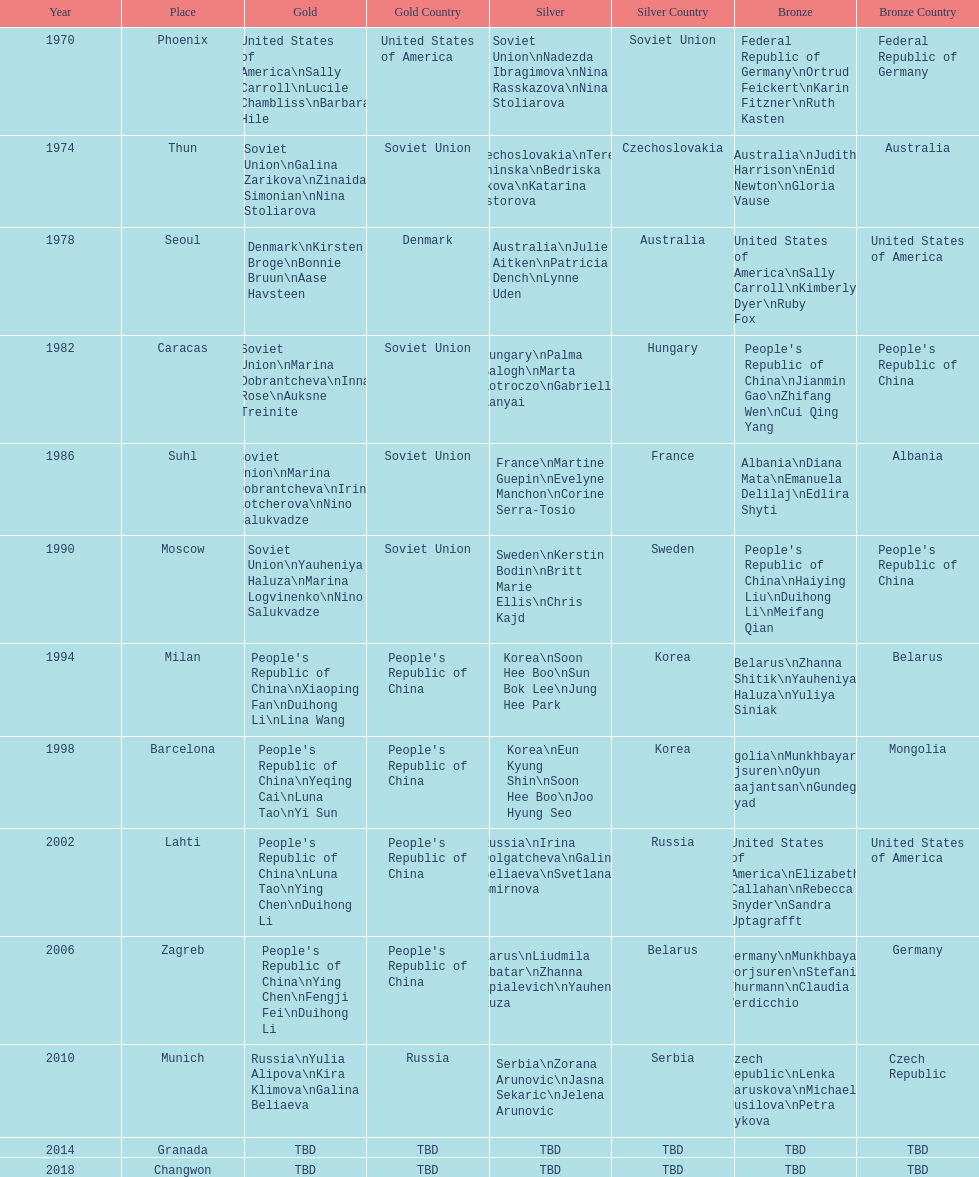How many times has germany won bronze? 2. 